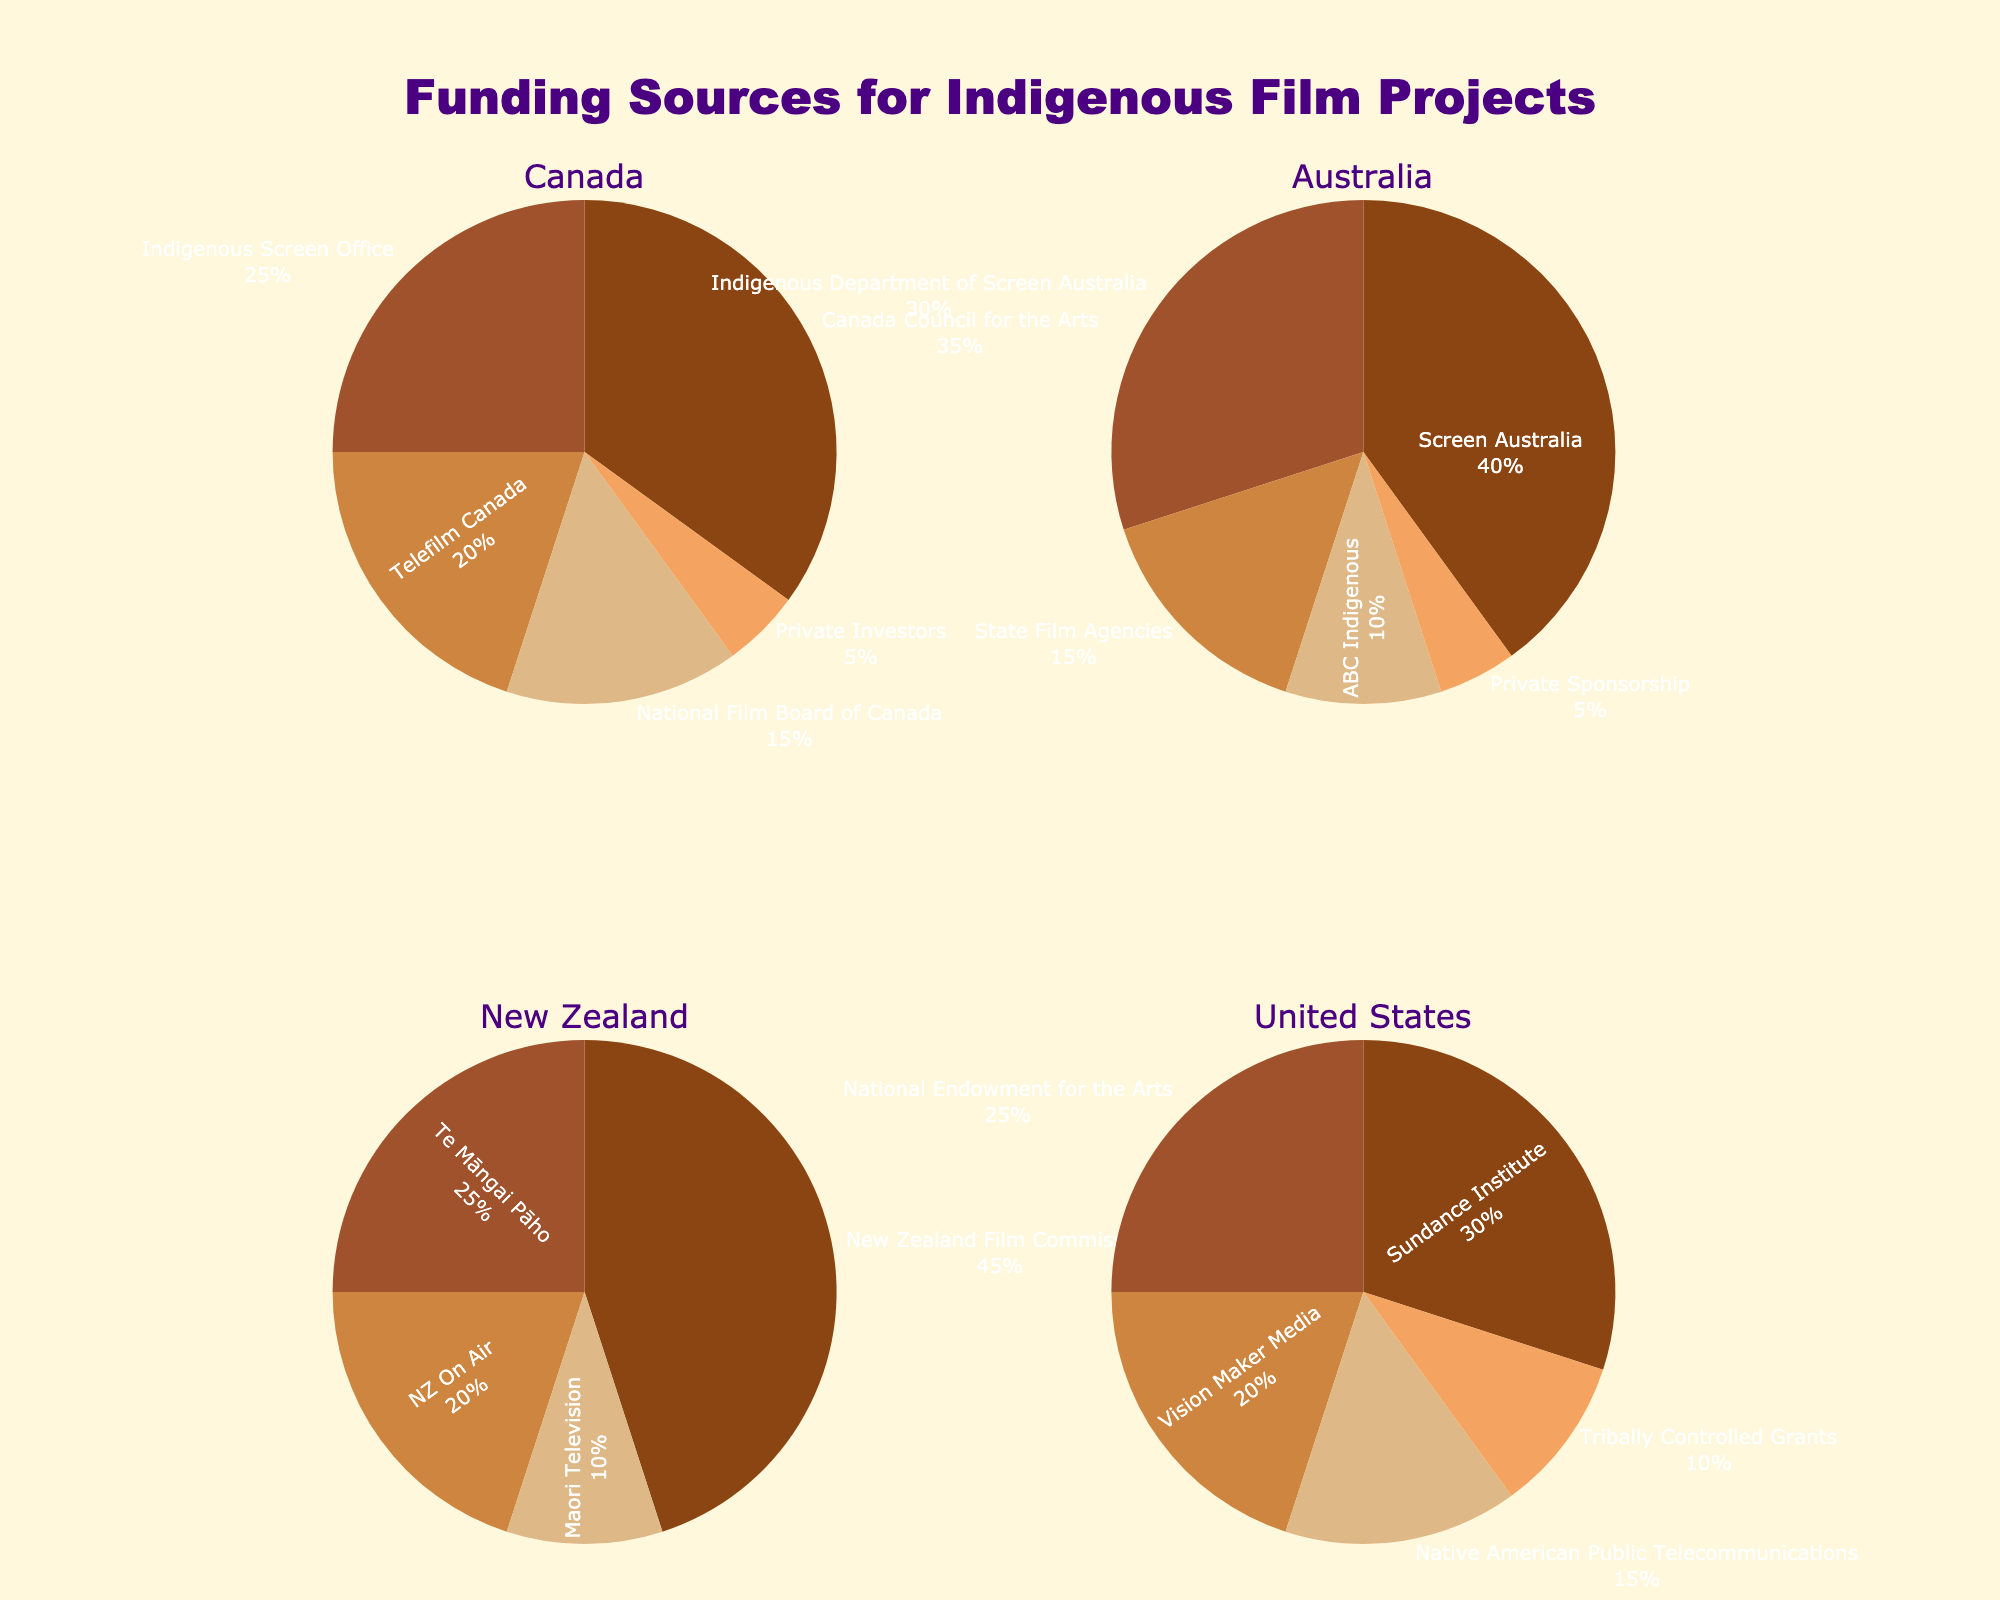What is the largest funding source for Indigenous film projects in Canada? The chart for Canada shows different funding sources and their respective percentages. The largest segment of the pie chart corresponds to the Canada Council for the Arts with 35%.
Answer: Canada Council for the Arts Which country has the highest percentage of funding coming from a single source, and what is that source? By comparing all the pie charts, New Zealand has the highest single funding source, with 45% from the New Zealand Film Commission.
Answer: New Zealand, New Zealand Film Commission What percentage of funding comes from the Indigenous Screen Office in Canada and the Indigenous Department of Screen Australia combined? Canada’s Indigenous Screen Office contributes 25%, and Australia's Indigenous Department of Screen Australia contributes 30%. Summing these gives 25% + 30% = 55%.
Answer: 55% Is there a private funding source shown in every country's pie chart? By inspecting each pie chart, private funding sources are present only in Canada (‘Private Investors’), and Australia (‘Private Sponsorship’). Other countries do not show private funding sources.
Answer: No What is the smallest funding source shown in the United States' pie chart, and what is its percentage? The smallest segment in the United States' pie chart corresponds to "Tribally Controlled Grants" at 10%.
Answer: Tribally Controlled Grants, 10% Which country has the most diversified funding sources in terms of the number of different categories, and how many are there? All countries have five funding sources each, as shown in their respective pie charts.
Answer: Tie, 5 sources each Which organization provides 30% of the funding for Indigenous film projects in the United States? The United States' pie chart shows "Sundance Institute" providing 30% of the funding.
Answer: Sundance Institute How much greater is the funding percentage from the National Film Board of Canada compared to Private Investors in Canada? The National Film Board of Canada provides 15%, while Private Investors provide 5%. The difference is 15% - 5% = 10%.
Answer: 10% What funding source is the second largest in New Zealand, and what percentage does it contribute? New Zealand's second-largest funding source is Te Māngai Pāho, which contributes 25%.
Answer: Te Māngai Pāho, 25% Between Australia and the United States, which country’s top two funding sources combined contribute a higher percentage of funding for Indigenous film projects, and what is that percentage? In Australia, Screen Australia (40%) and Indigenous Department of Screen Australia (30%) together contribute 70%. In the US, Sundance Institute (30%) and National Endowment for the Arts (25%) together provide 55%. Therefore, Australia’s top two sources contribute more.
Answer: Australia, 70% 